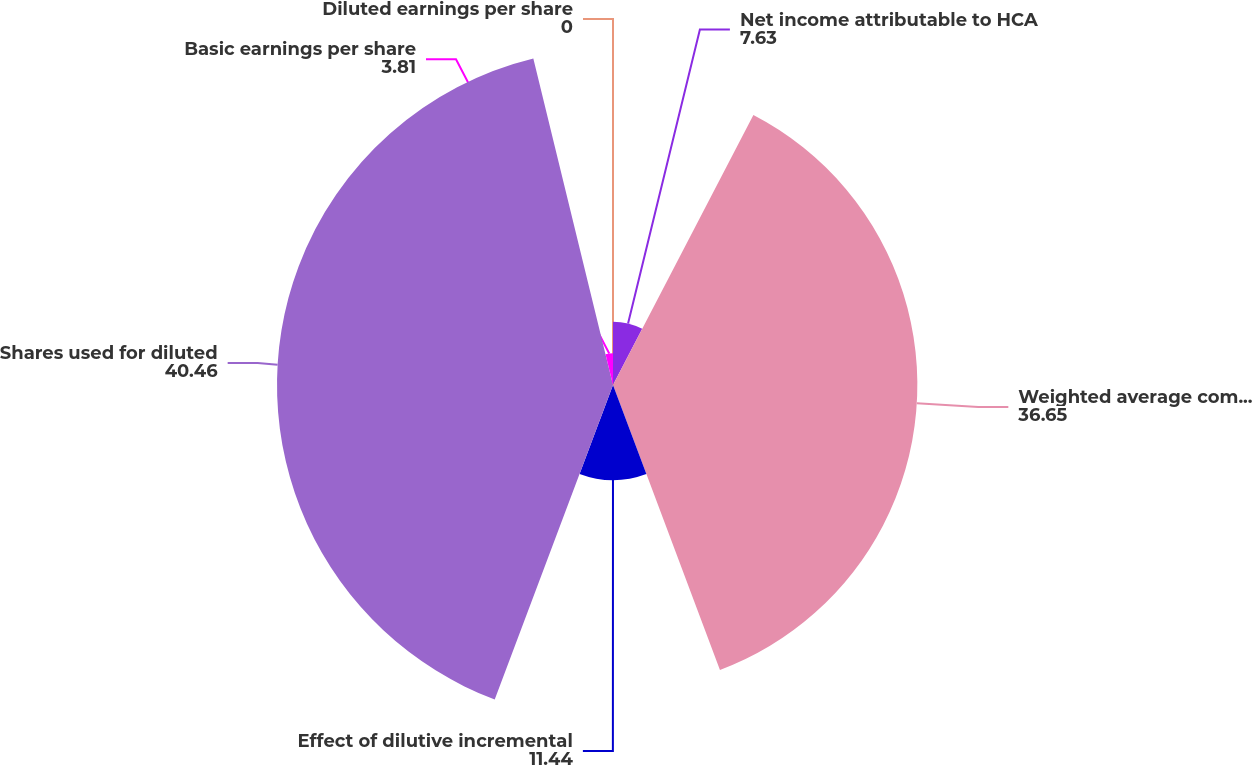Convert chart. <chart><loc_0><loc_0><loc_500><loc_500><pie_chart><fcel>Net income attributable to HCA<fcel>Weighted average common shares<fcel>Effect of dilutive incremental<fcel>Shares used for diluted<fcel>Basic earnings per share<fcel>Diluted earnings per share<nl><fcel>7.63%<fcel>36.65%<fcel>11.44%<fcel>40.46%<fcel>3.81%<fcel>0.0%<nl></chart> 